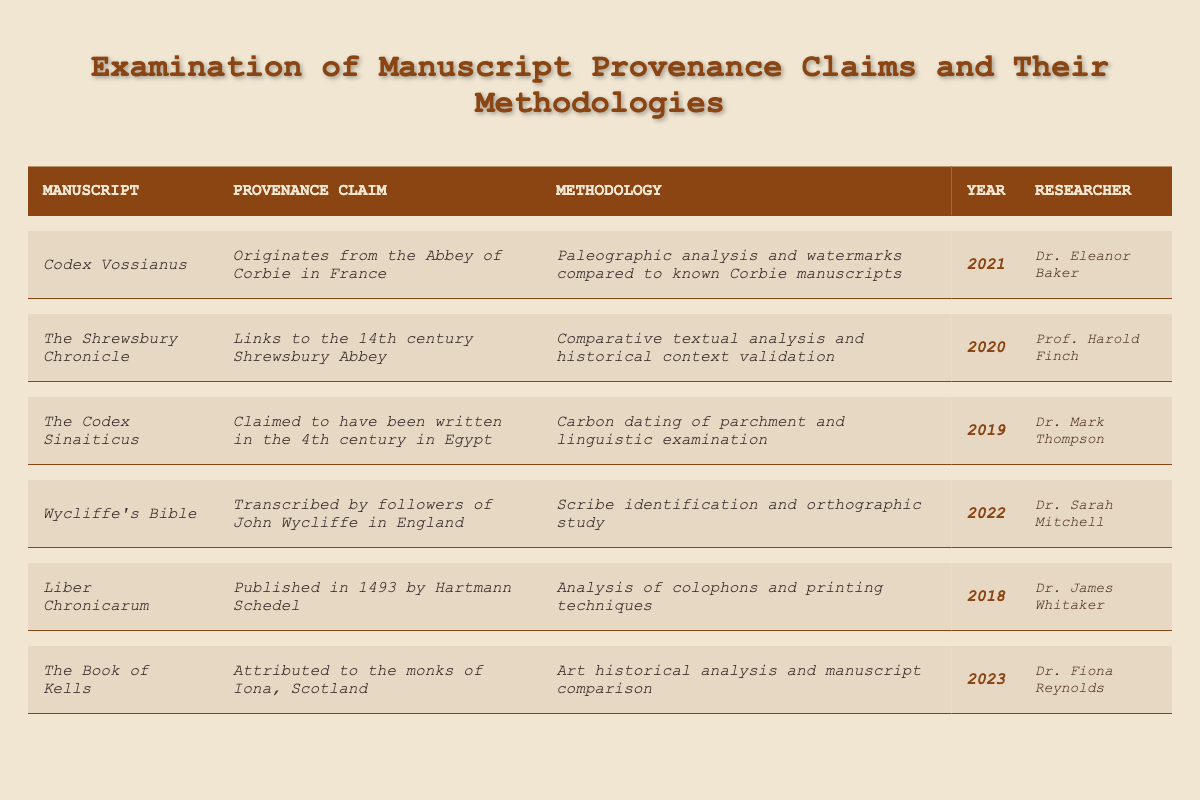What manuscript was examined in 2021? According to the table, the manuscript examined in 2021 is "Codex Vossianus."
Answer: Codex Vossianus Who conducted the examination of The Codex Sinaiticus? The table lists Dr. Mark Thompson as the researcher who examined The Codex Sinaiticus.
Answer: Dr. Mark Thompson What was the methodology used for the examination of Wycliffe's Bible? The table specifies that the methodology for Wycliffe's Bible was "Scribe identification and orthographic study."
Answer: Scribe identification and orthographic study Which manuscript has its provenance linked to the 14th century? The table states that The Shrewsbury Chronicle is linked to the 14th century Shrewsbury Abbey.
Answer: The Shrewsbury Chronicle What are the two methodologies mentioned for the Codex Vossianus? For Codex Vossianus, the methodologies are "Paleographic analysis" and "watermarks compared to known Corbie manuscripts."
Answer: Paleographic analysis and watermarks compared to known Corbie manuscripts How many researchers are listed in the table? There are six researchers listed in the table; by counting, we establish that the unique names are Dr. Eleanor Baker, Prof. Harold Finch, Dr. Mark Thompson, Dr. Sarah Mitchell, Dr. James Whitaker, and Dr. Fiona Reynolds.
Answer: 6 Which manuscript is attributed to monks from Iona and when was it examined? The Book of Kells is attributed to the monks of Iona, Scotland, and was examined in 2023.
Answer: The Book of Kells, 2023 In what year was the analysis of colophons and printing techniques conducted? The table shows that the analysis of colophons and printing techniques for Liber Chronicarum was conducted in 2018.
Answer: 2018 Is Wycliffe's Bible the earliest manuscript listed in the table? No, Wycliffe's Bible is examined in 2022, while The Codex Sinaiticus was examined in 2019, making The Codex Sinaiticus the earliest manuscript listed.
Answer: No Which researcher has the most recent examination year? By checking the years in the table, Dr. Fiona Reynolds conducted the most recent examination of The Book of Kells in 2023.
Answer: Dr. Fiona Reynolds What types of analysis were used for examining The Codex Sinaiticus? The methodology for The Codex Sinaiticus included carbon dating of parchment and linguistic examination according to the table.
Answer: Carbon dating of parchment and linguistic examination If the manuscripts examined in 2021 and 2022 are compared, how many years apart are they? The manuscript examined in 2021 is Codex Vossianus and the one in 2022 is Wycliffe's Bible; therefore, they are examined one year apart (2022-2021=1).
Answer: 1 year What is the common element among the methodologies of Codex Vossianus and The Book of Kells? Both methodologies involve analysis techniques: Codex Vossianus uses paleographic analysis and watermarks, while The Book of Kells uses art historical analysis and manuscript comparison, both examining aspects of textual provenance.
Answer: Analysis techniques 